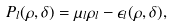<formula> <loc_0><loc_0><loc_500><loc_500>P _ { l } ( \rho , \delta ) = \mu _ { l } \rho _ { l } - \epsilon _ { l } ( \rho , \delta ) ,</formula> 